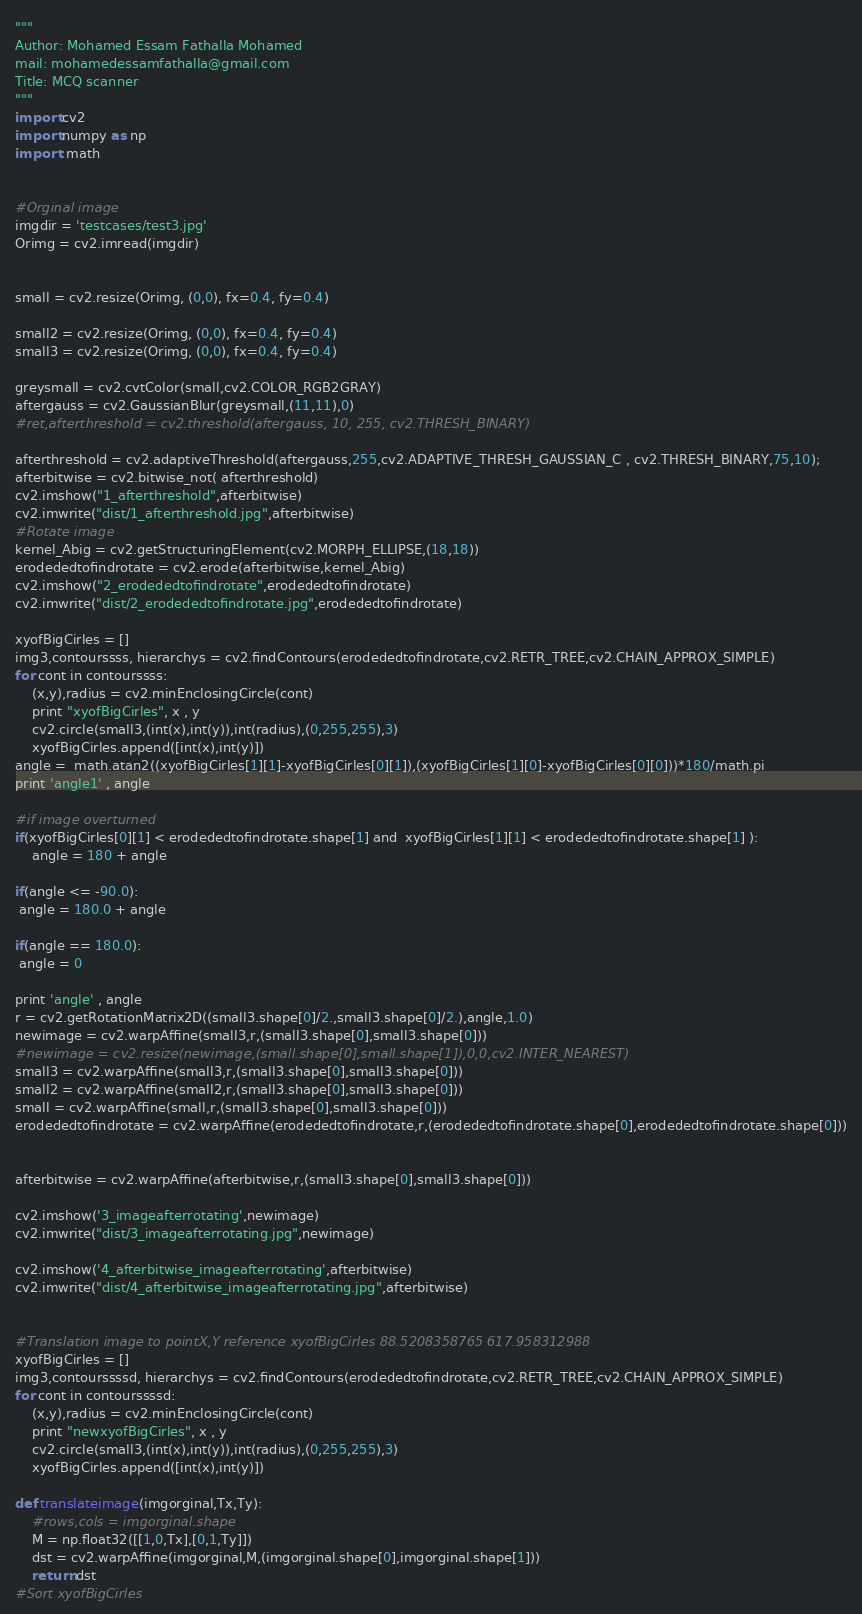Convert code to text. <code><loc_0><loc_0><loc_500><loc_500><_Python_>"""
Author: Mohamed Essam Fathalla Mohamed
mail: mohamedessamfathalla@gmail.com
Title: MCQ scanner
"""
import cv2
import numpy as np
import  math


#Orginal image
imgdir = 'testcases/test3.jpg'
Orimg = cv2.imread(imgdir)


small = cv2.resize(Orimg, (0,0), fx=0.4, fy=0.4)

small2 = cv2.resize(Orimg, (0,0), fx=0.4, fy=0.4)
small3 = cv2.resize(Orimg, (0,0), fx=0.4, fy=0.4)

greysmall = cv2.cvtColor(small,cv2.COLOR_RGB2GRAY)
aftergauss = cv2.GaussianBlur(greysmall,(11,11),0)
#ret,afterthreshold = cv2.threshold(aftergauss, 10, 255, cv2.THRESH_BINARY)

afterthreshold = cv2.adaptiveThreshold(aftergauss,255,cv2.ADAPTIVE_THRESH_GAUSSIAN_C , cv2.THRESH_BINARY,75,10);
afterbitwise = cv2.bitwise_not( afterthreshold)
cv2.imshow("1_afterthreshold",afterbitwise)
cv2.imwrite("dist/1_afterthreshold.jpg",afterbitwise)
#Rotate image
kernel_Abig = cv2.getStructuringElement(cv2.MORPH_ELLIPSE,(18,18))
erodededtofindrotate = cv2.erode(afterbitwise,kernel_Abig)
cv2.imshow("2_erodededtofindrotate",erodededtofindrotate)
cv2.imwrite("dist/2_erodededtofindrotate.jpg",erodededtofindrotate)

xyofBigCirles = []
img3,contourssss, hierarchys = cv2.findContours(erodededtofindrotate,cv2.RETR_TREE,cv2.CHAIN_APPROX_SIMPLE)
for cont in contourssss:
    (x,y),radius = cv2.minEnclosingCircle(cont)
    print "xyofBigCirles", x , y
    cv2.circle(small3,(int(x),int(y)),int(radius),(0,255,255),3)
    xyofBigCirles.append([int(x),int(y)])
angle =  math.atan2((xyofBigCirles[1][1]-xyofBigCirles[0][1]),(xyofBigCirles[1][0]-xyofBigCirles[0][0]))*180/math.pi
print 'angle1' , angle

#if image overturned
if(xyofBigCirles[0][1] < erodededtofindrotate.shape[1] and  xyofBigCirles[1][1] < erodededtofindrotate.shape[1] ):
    angle = 180 + angle

if(angle <= -90.0):
 angle = 180.0 + angle

if(angle == 180.0):
 angle = 0

print 'angle' , angle
r = cv2.getRotationMatrix2D((small3.shape[0]/2.,small3.shape[0]/2.),angle,1.0)
newimage = cv2.warpAffine(small3,r,(small3.shape[0],small3.shape[0]))
#newimage = cv2.resize(newimage,(small.shape[0],small.shape[1]),0,0,cv2.INTER_NEAREST)
small3 = cv2.warpAffine(small3,r,(small3.shape[0],small3.shape[0]))
small2 = cv2.warpAffine(small2,r,(small3.shape[0],small3.shape[0]))
small = cv2.warpAffine(small,r,(small3.shape[0],small3.shape[0]))
erodededtofindrotate = cv2.warpAffine(erodededtofindrotate,r,(erodededtofindrotate.shape[0],erodededtofindrotate.shape[0]))


afterbitwise = cv2.warpAffine(afterbitwise,r,(small3.shape[0],small3.shape[0]))

cv2.imshow('3_imageafterrotating',newimage)
cv2.imwrite("dist/3_imageafterrotating.jpg",newimage)

cv2.imshow('4_afterbitwise_imageafterrotating',afterbitwise)
cv2.imwrite("dist/4_afterbitwise_imageafterrotating.jpg",afterbitwise)


#Translation image to pointX,Y reference xyofBigCirles 88.5208358765 617.958312988
xyofBigCirles = []
img3,contourssssd, hierarchys = cv2.findContours(erodededtofindrotate,cv2.RETR_TREE,cv2.CHAIN_APPROX_SIMPLE)
for cont in contourssssd:
    (x,y),radius = cv2.minEnclosingCircle(cont)
    print "newxyofBigCirles", x , y
    cv2.circle(small3,(int(x),int(y)),int(radius),(0,255,255),3)
    xyofBigCirles.append([int(x),int(y)])

def translateimage(imgorginal,Tx,Ty):
    #rows,cols = imgorginal.shape
    M = np.float32([[1,0,Tx],[0,1,Ty]])
    dst = cv2.warpAffine(imgorginal,M,(imgorginal.shape[0],imgorginal.shape[1]))
    return dst
#Sort xyofBigCirles</code> 